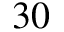Convert formula to latex. <formula><loc_0><loc_0><loc_500><loc_500>3 0</formula> 